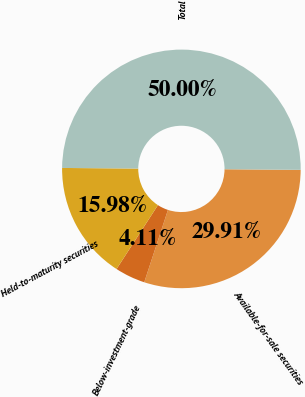<chart> <loc_0><loc_0><loc_500><loc_500><pie_chart><fcel>Available-for-sale securities<fcel>Below-investment-grade<fcel>Held-to-maturity securities<fcel>Total<nl><fcel>29.91%<fcel>4.11%<fcel>15.98%<fcel>50.0%<nl></chart> 